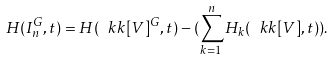<formula> <loc_0><loc_0><loc_500><loc_500>H ( I ^ { G } _ { n } , t ) = H ( \ k k [ V ] ^ { G } , t ) - ( \sum _ { k = 1 } ^ { n } H _ { k } ( \ k k [ V ] , t ) ) .</formula> 